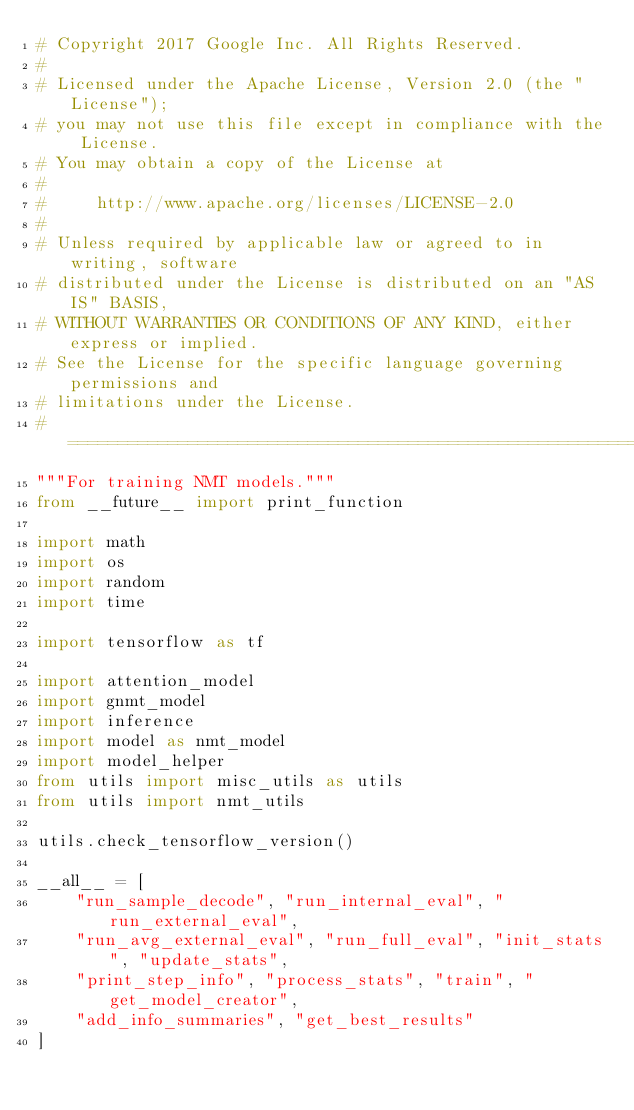Convert code to text. <code><loc_0><loc_0><loc_500><loc_500><_Python_># Copyright 2017 Google Inc. All Rights Reserved.
#
# Licensed under the Apache License, Version 2.0 (the "License");
# you may not use this file except in compliance with the License.
# You may obtain a copy of the License at
#
#     http://www.apache.org/licenses/LICENSE-2.0
#
# Unless required by applicable law or agreed to in writing, software
# distributed under the License is distributed on an "AS IS" BASIS,
# WITHOUT WARRANTIES OR CONDITIONS OF ANY KIND, either express or implied.
# See the License for the specific language governing permissions and
# limitations under the License.
# ==============================================================================
"""For training NMT models."""
from __future__ import print_function

import math
import os
import random
import time

import tensorflow as tf

import attention_model
import gnmt_model
import inference
import model as nmt_model
import model_helper
from utils import misc_utils as utils
from utils import nmt_utils

utils.check_tensorflow_version()

__all__ = [
    "run_sample_decode", "run_internal_eval", "run_external_eval",
    "run_avg_external_eval", "run_full_eval", "init_stats", "update_stats",
    "print_step_info", "process_stats", "train", "get_model_creator",
    "add_info_summaries", "get_best_results"
]

</code> 